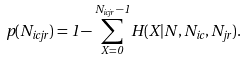<formula> <loc_0><loc_0><loc_500><loc_500>p ( N _ { i c j r } ) = 1 - \sum ^ { N _ { i c j r } - 1 } _ { X = 0 } H ( X | N , N _ { i c } , N _ { j r } ) .</formula> 